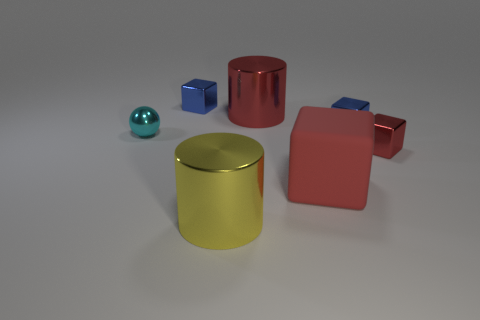Subtract all small blocks. How many blocks are left? 1 Add 2 tiny red metal cubes. How many objects exist? 9 Subtract all cyan cubes. Subtract all green balls. How many cubes are left? 4 Subtract all cylinders. How many objects are left? 5 Subtract 0 purple spheres. How many objects are left? 7 Subtract all blue things. Subtract all large red metallic objects. How many objects are left? 4 Add 2 metallic balls. How many metallic balls are left? 3 Add 5 small metallic things. How many small metallic things exist? 9 